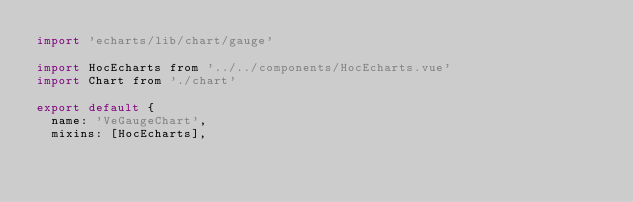<code> <loc_0><loc_0><loc_500><loc_500><_JavaScript_>import 'echarts/lib/chart/gauge'

import HocEcharts from '../../components/HocEcharts.vue'
import Chart from './chart'

export default {
  name: 'VeGaugeChart',
  mixins: [HocEcharts],</code> 